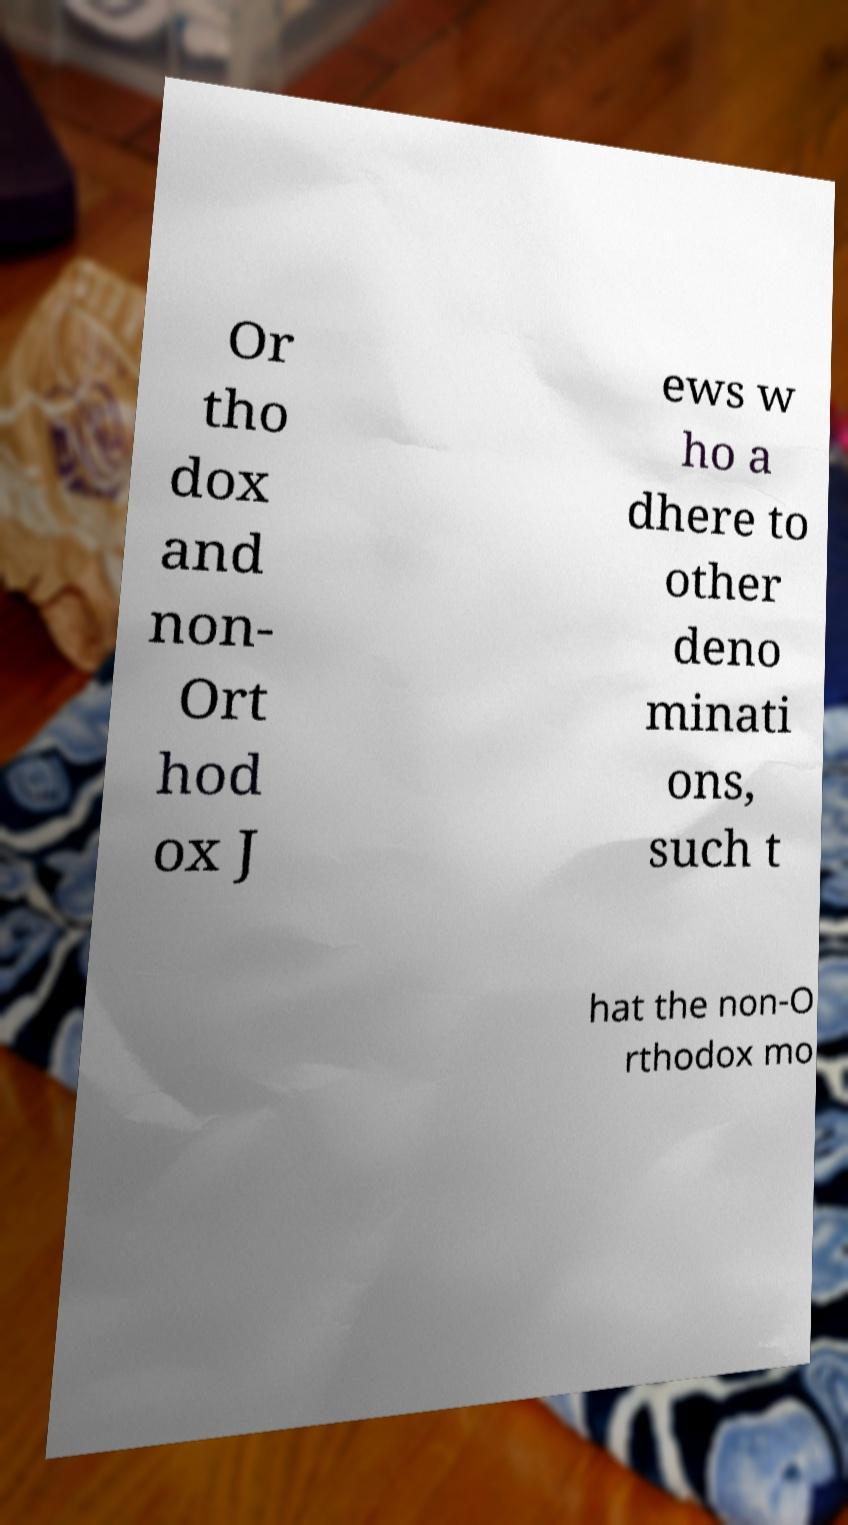Could you assist in decoding the text presented in this image and type it out clearly? Or tho dox and non- Ort hod ox J ews w ho a dhere to other deno minati ons, such t hat the non-O rthodox mo 